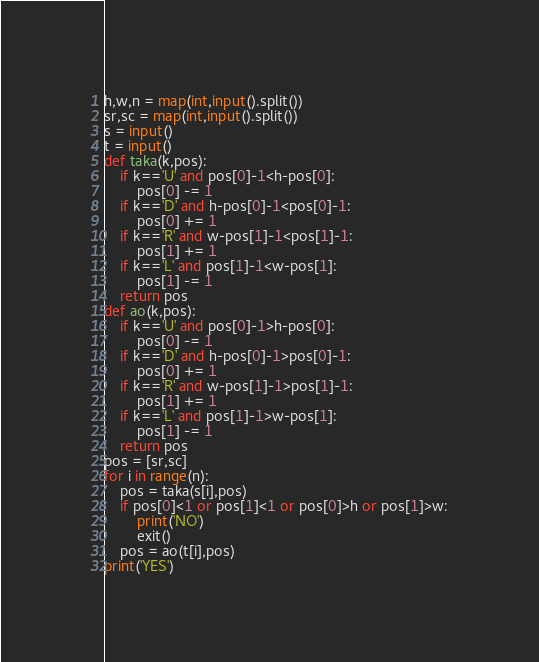Convert code to text. <code><loc_0><loc_0><loc_500><loc_500><_Python_>h,w,n = map(int,input().split())
sr,sc = map(int,input().split())
s = input()
t = input()
def taka(k,pos):
    if k=='U' and pos[0]-1<h-pos[0]:
        pos[0] -= 1
    if k=='D' and h-pos[0]-1<pos[0]-1:
        pos[0] += 1
    if k=='R' and w-pos[1]-1<pos[1]-1:
        pos[1] += 1
    if k=='L' and pos[1]-1<w-pos[1]:
        pos[1] -= 1
    return pos
def ao(k,pos):
    if k=='U' and pos[0]-1>h-pos[0]:
        pos[0] -= 1
    if k=='D' and h-pos[0]-1>pos[0]-1:
        pos[0] += 1
    if k=='R' and w-pos[1]-1>pos[1]-1:
        pos[1] += 1
    if k=='L' and pos[1]-1>w-pos[1]:
        pos[1] -= 1
    return pos
pos = [sr,sc]
for i in range(n):
    pos = taka(s[i],pos)
    if pos[0]<1 or pos[1]<1 or pos[0]>h or pos[1]>w:
        print('NO')
        exit()
    pos = ao(t[i],pos)
print('YES')</code> 